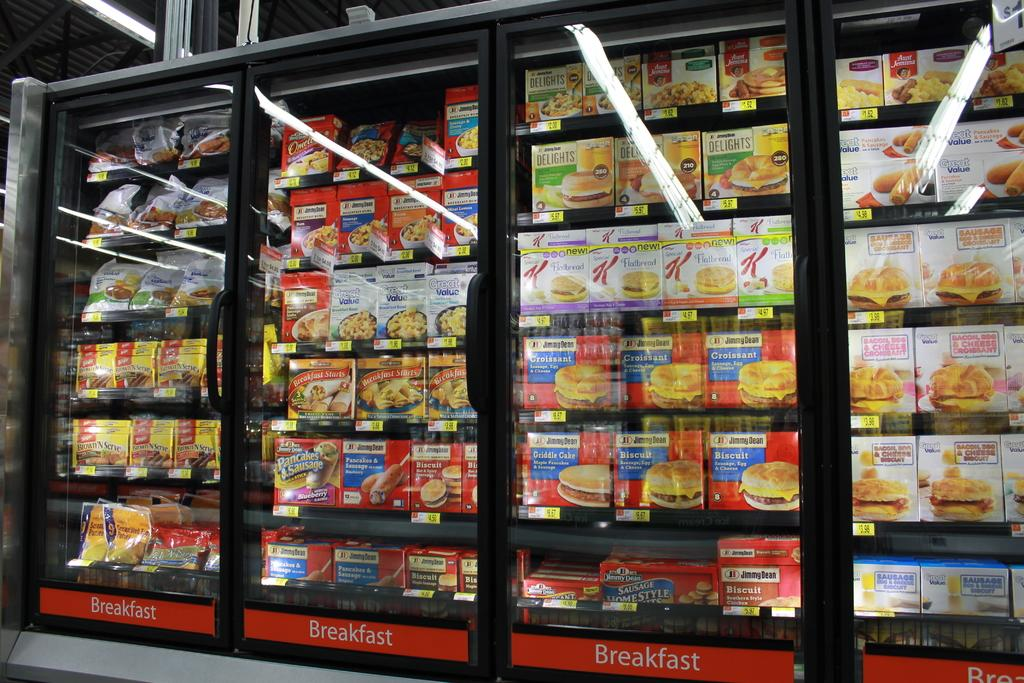What type of items can be seen in the foreground of the image? There are food packets, covers, and sachets in the foreground of the image. Where are these items located? The items are in cupboards. What can be seen in the background of the image? There are lights on a rooftop in the background of the image. Can you describe the setting where the image might have been taken? The image might have been taken in a shop. What type of joke is being told by the meat in the image? There is no meat present in the image, and therefore no joke can be told by it. 